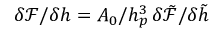<formula> <loc_0><loc_0><loc_500><loc_500>\delta \mathcal { F } / \delta h = A _ { 0 } / h _ { p } ^ { 3 } \, \delta \tilde { \mathcal { F } } / \delta \tilde { h }</formula> 